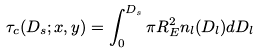Convert formula to latex. <formula><loc_0><loc_0><loc_500><loc_500>\tau _ { c } ( D _ { s } ; x , y ) = \int _ { 0 } ^ { D _ { s } } \pi R _ { E } ^ { 2 } n _ { l } ( D _ { l } ) d D _ { l }</formula> 